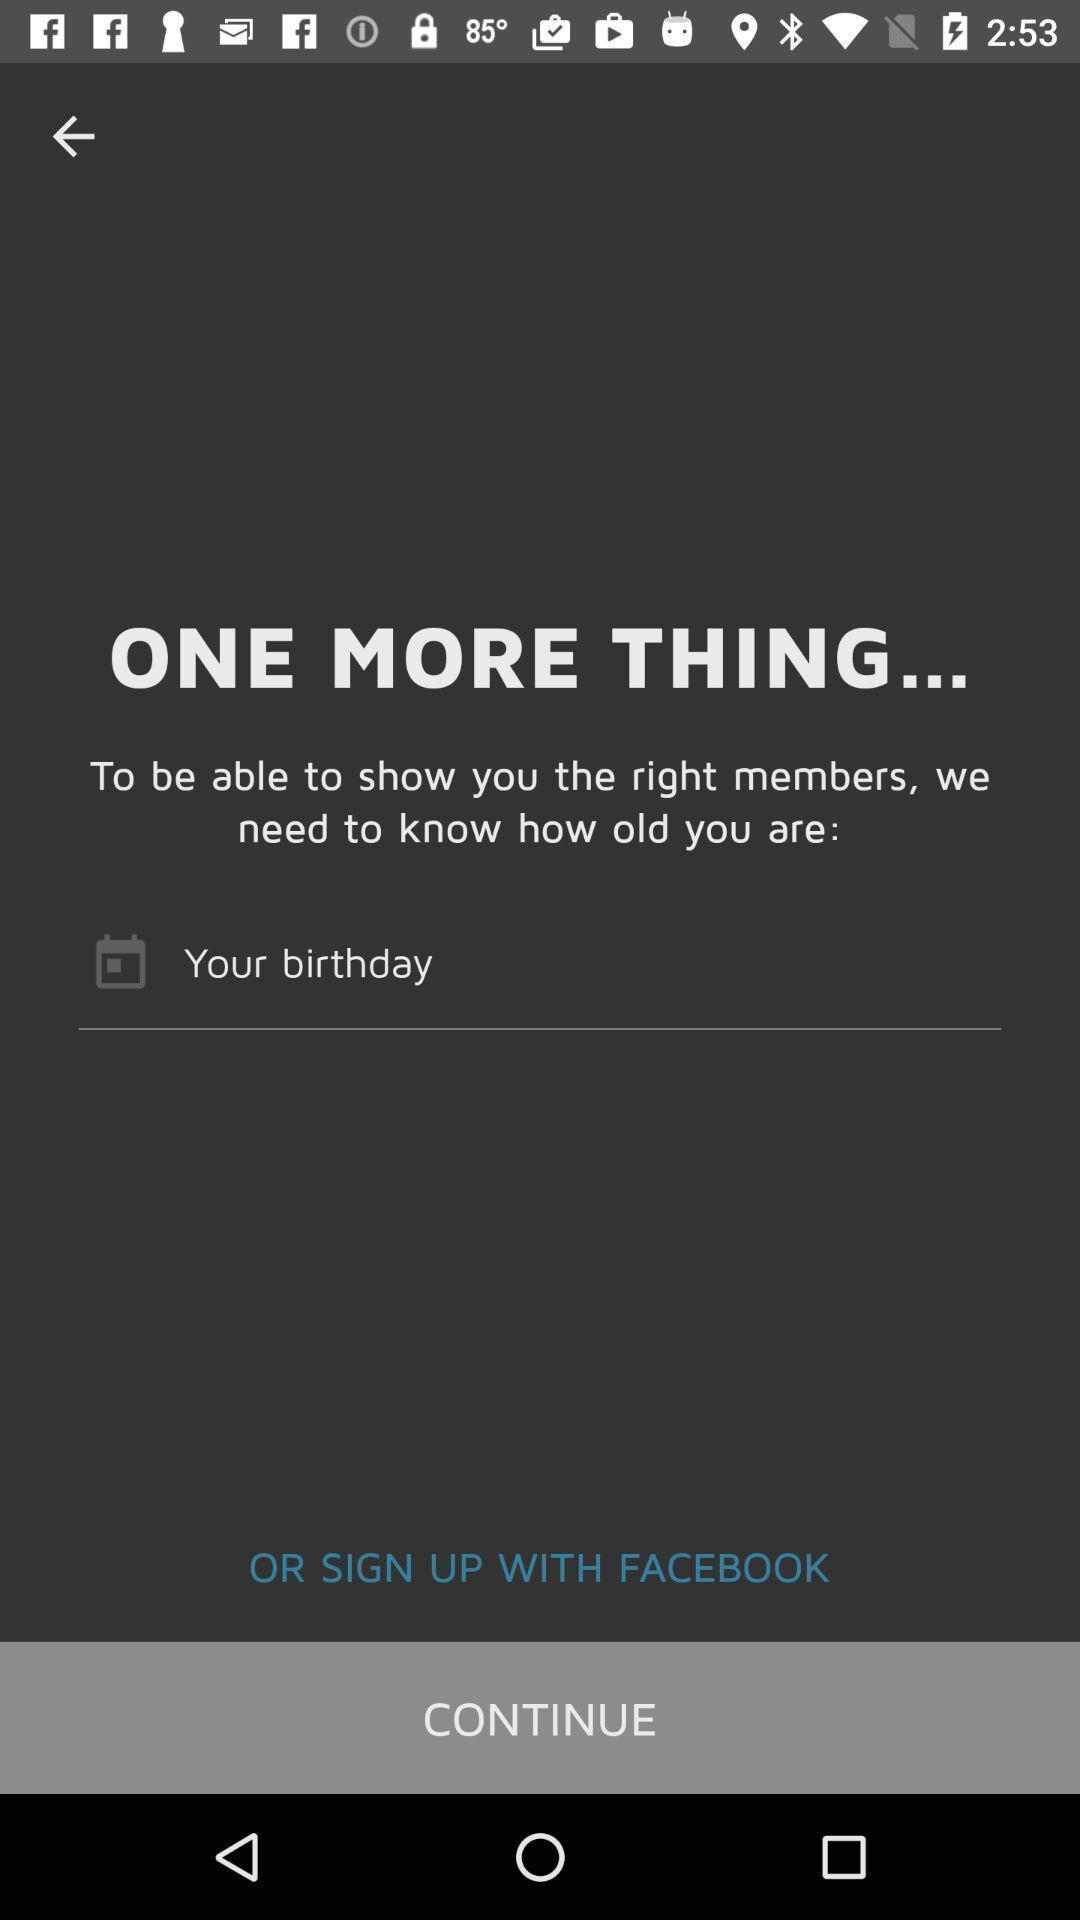Provide a description of this screenshot. Welcome page displaying options to continue. 